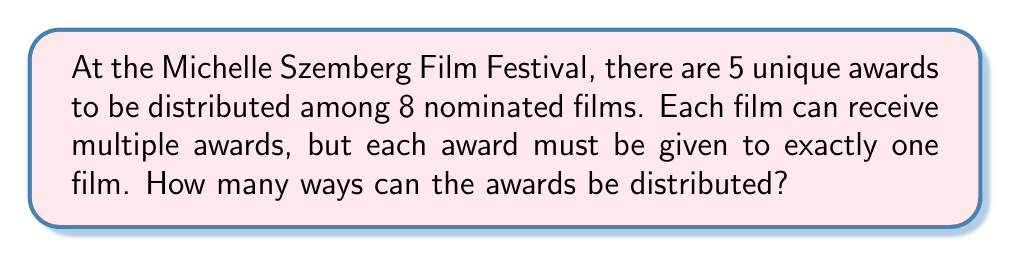Show me your answer to this math problem. Let's approach this step-by-step:

1) This is a problem of distributing distinct objects (awards) into distinct containers (films), where each container can hold multiple objects.

2) For each award, we have 8 choices of films to give it to, and these choices are independent of each other.

3) We can use the multiplication principle here. For each of the 5 awards, we make a choice from 8 options.

4) Therefore, the total number of ways to distribute the awards is:

   $$8 \times 8 \times 8 \times 8 \times 8 = 8^5$$

5) We can calculate this:
   
   $$8^5 = 32,768$$

This result represents all possible ways to distribute 5 distinct awards among 8 films, allowing for multiple awards per film.
Answer: $32,768$ 